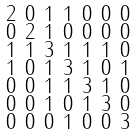<formula> <loc_0><loc_0><loc_500><loc_500>\begin{smallmatrix} 2 & 0 & 1 & 1 & 0 & 0 & 0 \\ 0 & 2 & 1 & 0 & 0 & 0 & 0 \\ 1 & 1 & 3 & 1 & 1 & 1 & 0 \\ 1 & 0 & 1 & 3 & 1 & 0 & 1 \\ 0 & 0 & 1 & 1 & 3 & 1 & 0 \\ 0 & 0 & 1 & 0 & 1 & 3 & 0 \\ 0 & 0 & 0 & 1 & 0 & 0 & 3 \end{smallmatrix}</formula> 